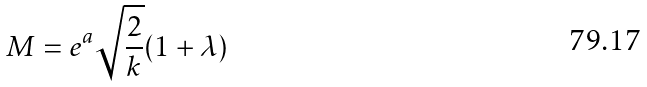Convert formula to latex. <formula><loc_0><loc_0><loc_500><loc_500>M = e ^ { a } \sqrt { \frac { 2 } { k } } ( 1 + \lambda )</formula> 